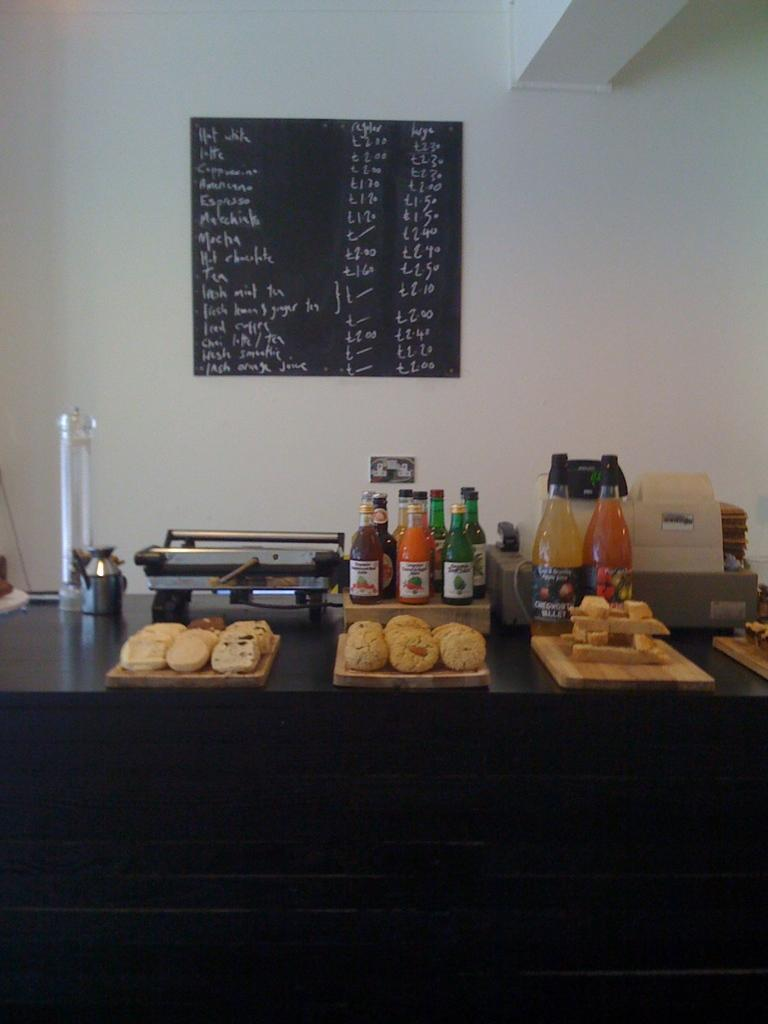What is on the table in the image? There is a tray with food, bottles, and a machine on the table. What can be seen on the wall in the image? There is a blackboard on the wall. What type of education is being provided by the secretary in the image? There is no secretary or education present in the image. What action is the machine performing in the image? The image does not show the machine performing any action; it is simply present on the table. 